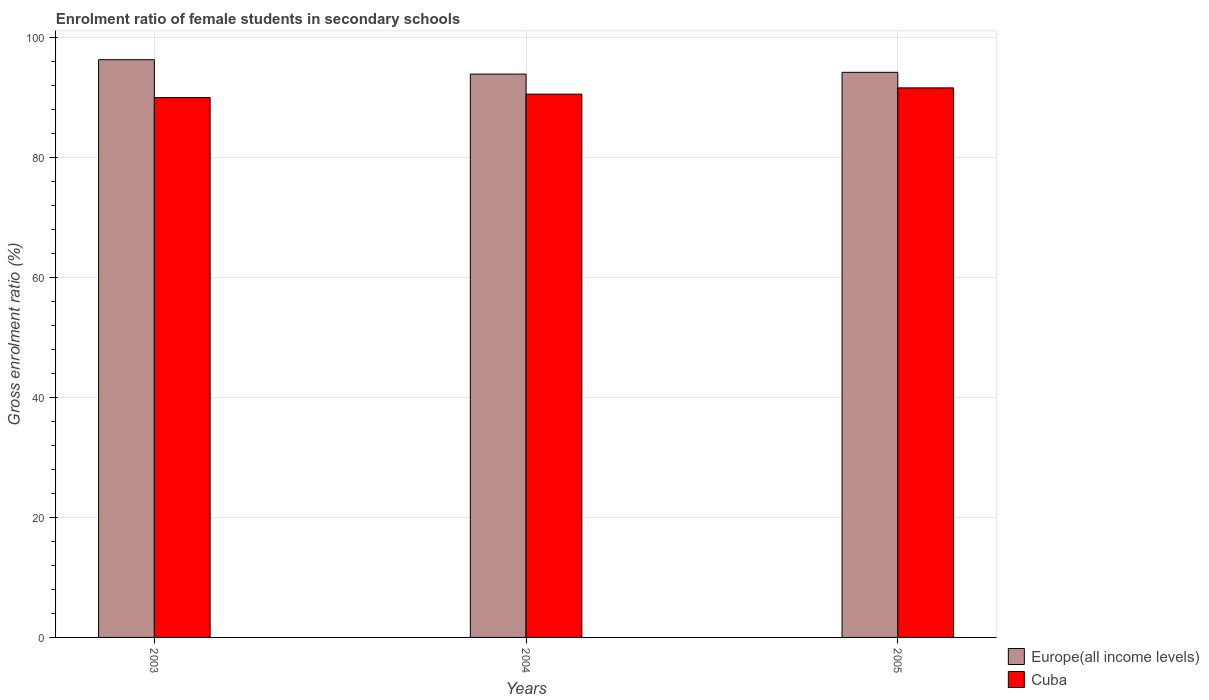How many different coloured bars are there?
Your response must be concise. 2. How many groups of bars are there?
Ensure brevity in your answer.  3. Are the number of bars per tick equal to the number of legend labels?
Give a very brief answer. Yes. Are the number of bars on each tick of the X-axis equal?
Your answer should be compact. Yes. How many bars are there on the 2nd tick from the left?
Your answer should be very brief. 2. How many bars are there on the 1st tick from the right?
Ensure brevity in your answer.  2. What is the label of the 2nd group of bars from the left?
Keep it short and to the point. 2004. In how many cases, is the number of bars for a given year not equal to the number of legend labels?
Offer a terse response. 0. What is the enrolment ratio of female students in secondary schools in Cuba in 2004?
Provide a succinct answer. 90.59. Across all years, what is the maximum enrolment ratio of female students in secondary schools in Cuba?
Your answer should be very brief. 91.64. Across all years, what is the minimum enrolment ratio of female students in secondary schools in Cuba?
Keep it short and to the point. 90.02. In which year was the enrolment ratio of female students in secondary schools in Cuba maximum?
Provide a succinct answer. 2005. What is the total enrolment ratio of female students in secondary schools in Cuba in the graph?
Make the answer very short. 272.25. What is the difference between the enrolment ratio of female students in secondary schools in Cuba in 2003 and that in 2005?
Offer a terse response. -1.62. What is the difference between the enrolment ratio of female students in secondary schools in Cuba in 2003 and the enrolment ratio of female students in secondary schools in Europe(all income levels) in 2005?
Provide a short and direct response. -4.21. What is the average enrolment ratio of female students in secondary schools in Europe(all income levels) per year?
Provide a short and direct response. 94.83. In the year 2003, what is the difference between the enrolment ratio of female students in secondary schools in Europe(all income levels) and enrolment ratio of female students in secondary schools in Cuba?
Your response must be concise. 6.31. What is the ratio of the enrolment ratio of female students in secondary schools in Cuba in 2003 to that in 2005?
Ensure brevity in your answer.  0.98. Is the enrolment ratio of female students in secondary schools in Europe(all income levels) in 2003 less than that in 2004?
Make the answer very short. No. What is the difference between the highest and the second highest enrolment ratio of female students in secondary schools in Europe(all income levels)?
Ensure brevity in your answer.  2.1. What is the difference between the highest and the lowest enrolment ratio of female students in secondary schools in Cuba?
Offer a terse response. 1.62. In how many years, is the enrolment ratio of female students in secondary schools in Europe(all income levels) greater than the average enrolment ratio of female students in secondary schools in Europe(all income levels) taken over all years?
Make the answer very short. 1. Is the sum of the enrolment ratio of female students in secondary schools in Cuba in 2003 and 2005 greater than the maximum enrolment ratio of female students in secondary schools in Europe(all income levels) across all years?
Your answer should be compact. Yes. What does the 1st bar from the left in 2005 represents?
Your answer should be compact. Europe(all income levels). What does the 1st bar from the right in 2004 represents?
Provide a short and direct response. Cuba. Are all the bars in the graph horizontal?
Provide a short and direct response. No. How many years are there in the graph?
Make the answer very short. 3. What is the difference between two consecutive major ticks on the Y-axis?
Your answer should be very brief. 20. Does the graph contain grids?
Your response must be concise. Yes. How many legend labels are there?
Offer a very short reply. 2. How are the legend labels stacked?
Make the answer very short. Vertical. What is the title of the graph?
Offer a terse response. Enrolment ratio of female students in secondary schools. Does "Gabon" appear as one of the legend labels in the graph?
Ensure brevity in your answer.  No. What is the label or title of the Y-axis?
Your response must be concise. Gross enrolment ratio (%). What is the Gross enrolment ratio (%) of Europe(all income levels) in 2003?
Your response must be concise. 96.34. What is the Gross enrolment ratio (%) in Cuba in 2003?
Your answer should be very brief. 90.02. What is the Gross enrolment ratio (%) in Europe(all income levels) in 2004?
Keep it short and to the point. 93.94. What is the Gross enrolment ratio (%) in Cuba in 2004?
Keep it short and to the point. 90.59. What is the Gross enrolment ratio (%) of Europe(all income levels) in 2005?
Offer a very short reply. 94.23. What is the Gross enrolment ratio (%) of Cuba in 2005?
Your answer should be compact. 91.64. Across all years, what is the maximum Gross enrolment ratio (%) in Europe(all income levels)?
Your response must be concise. 96.34. Across all years, what is the maximum Gross enrolment ratio (%) of Cuba?
Offer a terse response. 91.64. Across all years, what is the minimum Gross enrolment ratio (%) in Europe(all income levels)?
Keep it short and to the point. 93.94. Across all years, what is the minimum Gross enrolment ratio (%) of Cuba?
Offer a terse response. 90.02. What is the total Gross enrolment ratio (%) in Europe(all income levels) in the graph?
Ensure brevity in your answer.  284.5. What is the total Gross enrolment ratio (%) in Cuba in the graph?
Make the answer very short. 272.25. What is the difference between the Gross enrolment ratio (%) in Europe(all income levels) in 2003 and that in 2004?
Your answer should be compact. 2.4. What is the difference between the Gross enrolment ratio (%) in Cuba in 2003 and that in 2004?
Provide a succinct answer. -0.57. What is the difference between the Gross enrolment ratio (%) in Europe(all income levels) in 2003 and that in 2005?
Provide a succinct answer. 2.1. What is the difference between the Gross enrolment ratio (%) of Cuba in 2003 and that in 2005?
Give a very brief answer. -1.62. What is the difference between the Gross enrolment ratio (%) in Europe(all income levels) in 2004 and that in 2005?
Ensure brevity in your answer.  -0.29. What is the difference between the Gross enrolment ratio (%) in Cuba in 2004 and that in 2005?
Your response must be concise. -1.04. What is the difference between the Gross enrolment ratio (%) in Europe(all income levels) in 2003 and the Gross enrolment ratio (%) in Cuba in 2004?
Make the answer very short. 5.74. What is the difference between the Gross enrolment ratio (%) of Europe(all income levels) in 2003 and the Gross enrolment ratio (%) of Cuba in 2005?
Your answer should be compact. 4.7. What is the difference between the Gross enrolment ratio (%) in Europe(all income levels) in 2004 and the Gross enrolment ratio (%) in Cuba in 2005?
Provide a short and direct response. 2.3. What is the average Gross enrolment ratio (%) in Europe(all income levels) per year?
Ensure brevity in your answer.  94.83. What is the average Gross enrolment ratio (%) of Cuba per year?
Keep it short and to the point. 90.75. In the year 2003, what is the difference between the Gross enrolment ratio (%) of Europe(all income levels) and Gross enrolment ratio (%) of Cuba?
Offer a very short reply. 6.31. In the year 2004, what is the difference between the Gross enrolment ratio (%) of Europe(all income levels) and Gross enrolment ratio (%) of Cuba?
Make the answer very short. 3.34. In the year 2005, what is the difference between the Gross enrolment ratio (%) of Europe(all income levels) and Gross enrolment ratio (%) of Cuba?
Your answer should be compact. 2.59. What is the ratio of the Gross enrolment ratio (%) of Europe(all income levels) in 2003 to that in 2004?
Give a very brief answer. 1.03. What is the ratio of the Gross enrolment ratio (%) in Europe(all income levels) in 2003 to that in 2005?
Your answer should be very brief. 1.02. What is the ratio of the Gross enrolment ratio (%) of Cuba in 2003 to that in 2005?
Make the answer very short. 0.98. What is the ratio of the Gross enrolment ratio (%) in Europe(all income levels) in 2004 to that in 2005?
Give a very brief answer. 1. What is the ratio of the Gross enrolment ratio (%) of Cuba in 2004 to that in 2005?
Make the answer very short. 0.99. What is the difference between the highest and the second highest Gross enrolment ratio (%) of Europe(all income levels)?
Ensure brevity in your answer.  2.1. What is the difference between the highest and the second highest Gross enrolment ratio (%) of Cuba?
Keep it short and to the point. 1.04. What is the difference between the highest and the lowest Gross enrolment ratio (%) of Europe(all income levels)?
Give a very brief answer. 2.4. What is the difference between the highest and the lowest Gross enrolment ratio (%) of Cuba?
Ensure brevity in your answer.  1.62. 